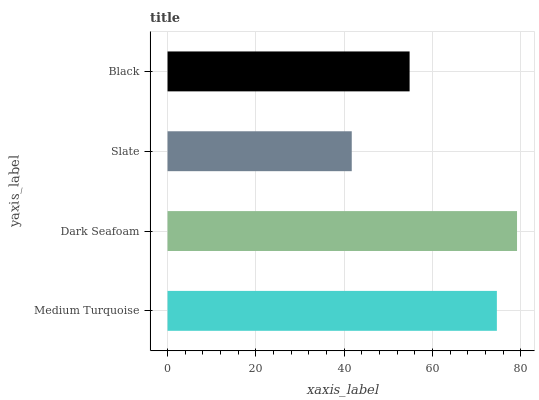Is Slate the minimum?
Answer yes or no. Yes. Is Dark Seafoam the maximum?
Answer yes or no. Yes. Is Dark Seafoam the minimum?
Answer yes or no. No. Is Slate the maximum?
Answer yes or no. No. Is Dark Seafoam greater than Slate?
Answer yes or no. Yes. Is Slate less than Dark Seafoam?
Answer yes or no. Yes. Is Slate greater than Dark Seafoam?
Answer yes or no. No. Is Dark Seafoam less than Slate?
Answer yes or no. No. Is Medium Turquoise the high median?
Answer yes or no. Yes. Is Black the low median?
Answer yes or no. Yes. Is Black the high median?
Answer yes or no. No. Is Dark Seafoam the low median?
Answer yes or no. No. 